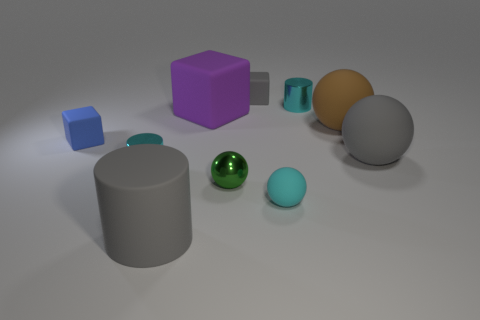There is a cube that is the same color as the big rubber cylinder; what is its material?
Your answer should be very brief. Rubber. Are there any other shiny things that have the same shape as the big brown thing?
Provide a succinct answer. Yes. There is a matte object on the left side of the matte cylinder; is its size the same as the large purple object?
Your answer should be compact. No. What size is the matte ball that is both in front of the blue matte block and on the left side of the large gray sphere?
Ensure brevity in your answer.  Small. What number of other things are there of the same material as the small blue cube
Your answer should be compact. 6. There is a gray object that is in front of the cyan matte thing; what size is it?
Ensure brevity in your answer.  Large. Is the color of the rubber cylinder the same as the metallic sphere?
Offer a terse response. No. What number of small objects are matte balls or brown matte balls?
Give a very brief answer. 1. Is there any other thing that is the same color as the metallic sphere?
Offer a very short reply. No. There is a green shiny ball; are there any large purple rubber objects in front of it?
Your response must be concise. No. 